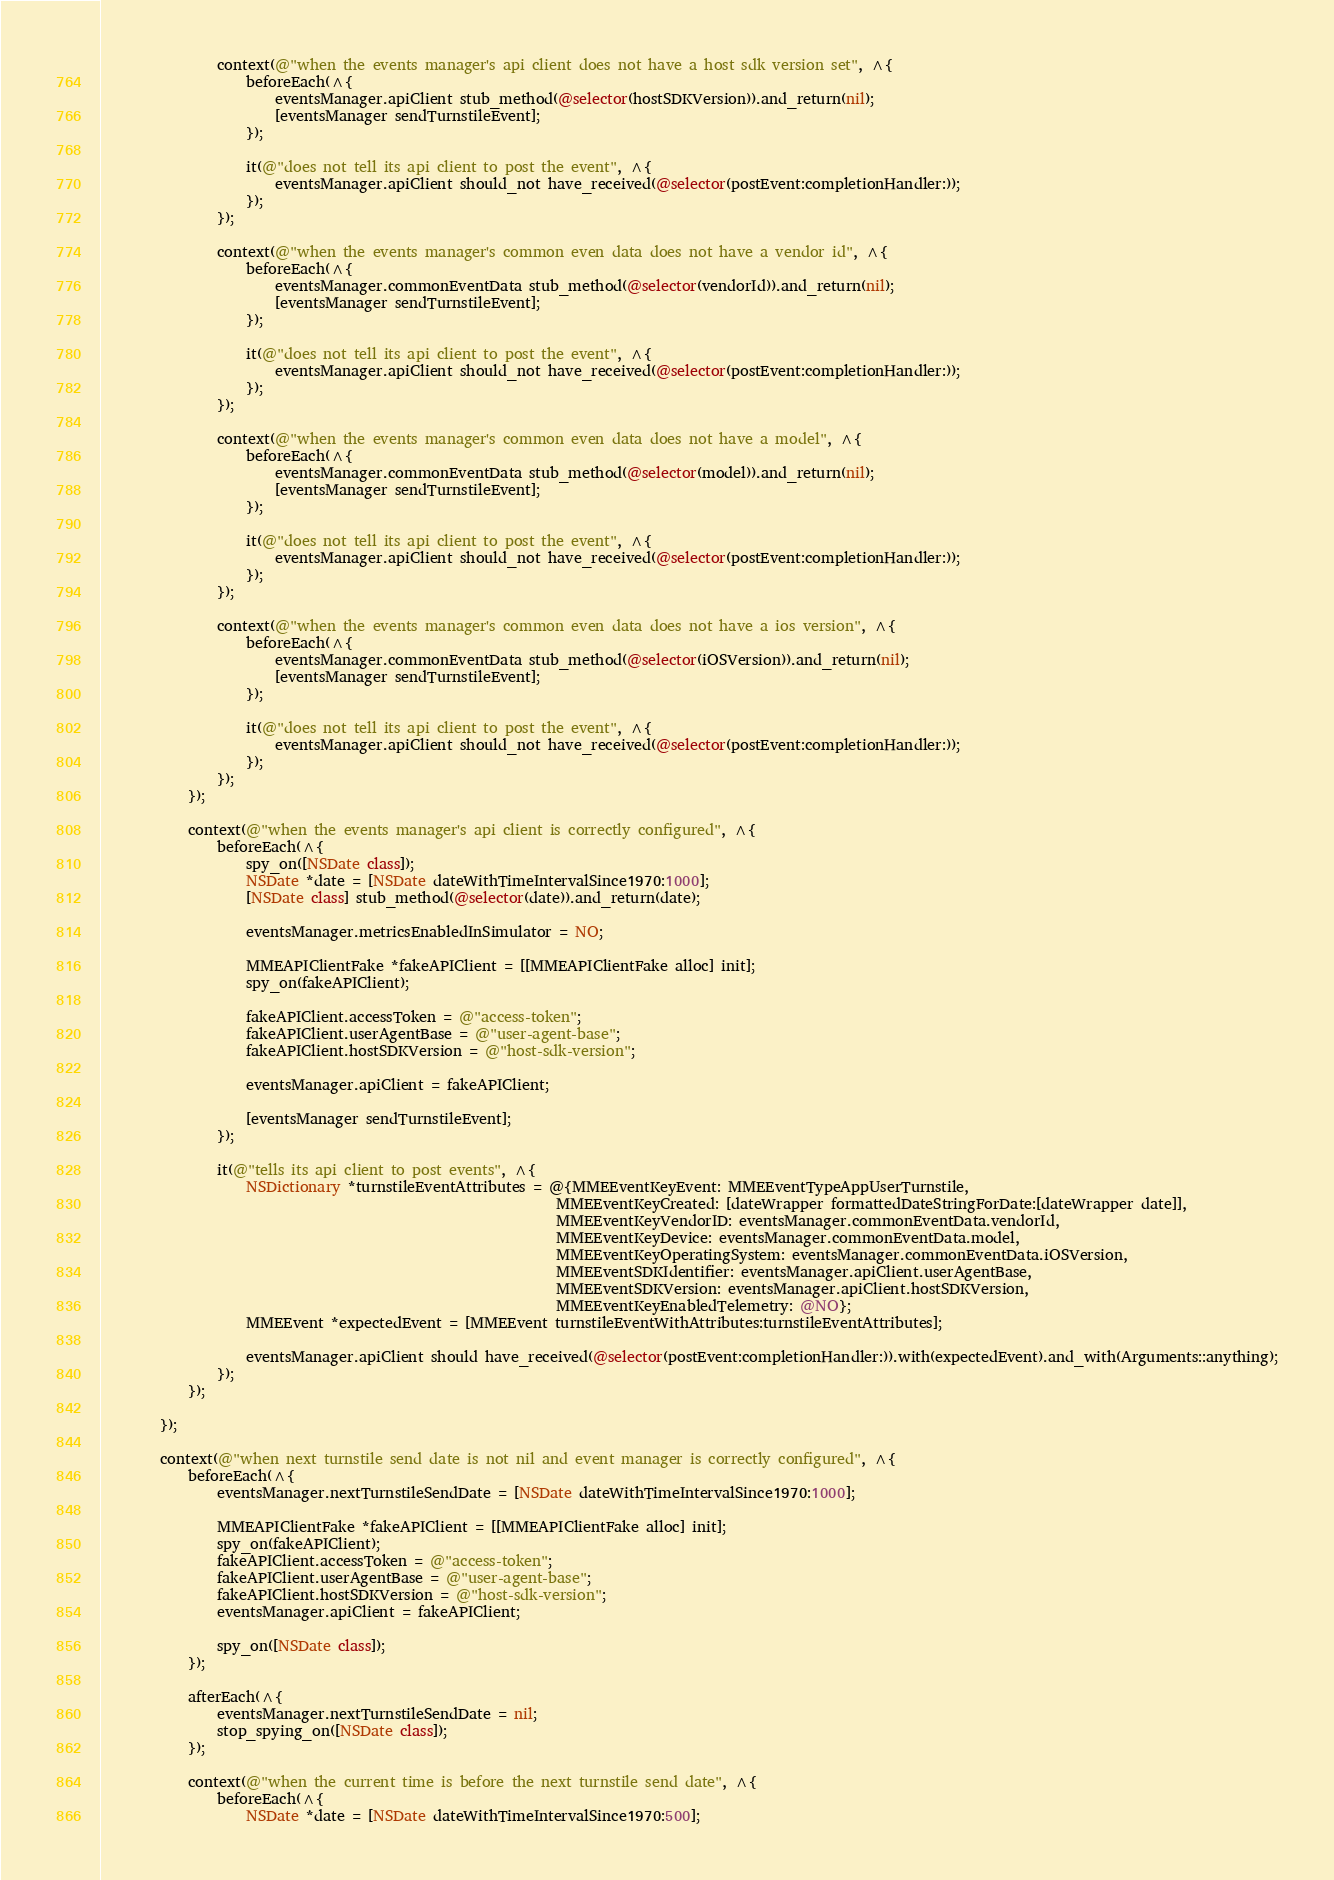Convert code to text. <code><loc_0><loc_0><loc_500><loc_500><_ObjectiveC_>                context(@"when the events manager's api client does not have a host sdk version set", ^{
                    beforeEach(^{
                        eventsManager.apiClient stub_method(@selector(hostSDKVersion)).and_return(nil);
                        [eventsManager sendTurnstileEvent];
                    });
                    
                    it(@"does not tell its api client to post the event", ^{
                        eventsManager.apiClient should_not have_received(@selector(postEvent:completionHandler:));
                    });
                });
                
                context(@"when the events manager's common even data does not have a vendor id", ^{
                    beforeEach(^{
                        eventsManager.commonEventData stub_method(@selector(vendorId)).and_return(nil);
                        [eventsManager sendTurnstileEvent];
                    });
                    
                    it(@"does not tell its api client to post the event", ^{
                        eventsManager.apiClient should_not have_received(@selector(postEvent:completionHandler:));
                    });
                });
                
                context(@"when the events manager's common even data does not have a model", ^{
                    beforeEach(^{
                        eventsManager.commonEventData stub_method(@selector(model)).and_return(nil);
                        [eventsManager sendTurnstileEvent];
                    });
                    
                    it(@"does not tell its api client to post the event", ^{
                        eventsManager.apiClient should_not have_received(@selector(postEvent:completionHandler:));
                    });
                });
                
                context(@"when the events manager's common even data does not have a ios version", ^{
                    beforeEach(^{
                        eventsManager.commonEventData stub_method(@selector(iOSVersion)).and_return(nil);
                        [eventsManager sendTurnstileEvent];
                    });
                    
                    it(@"does not tell its api client to post the event", ^{
                        eventsManager.apiClient should_not have_received(@selector(postEvent:completionHandler:));
                    });
                });
            });
            
            context(@"when the events manager's api client is correctly configured", ^{
                beforeEach(^{
                    spy_on([NSDate class]);
                    NSDate *date = [NSDate dateWithTimeIntervalSince1970:1000];
                    [NSDate class] stub_method(@selector(date)).and_return(date);
                    
                    eventsManager.metricsEnabledInSimulator = NO;
                    
                    MMEAPIClientFake *fakeAPIClient = [[MMEAPIClientFake alloc] init];
                    spy_on(fakeAPIClient);
                    
                    fakeAPIClient.accessToken = @"access-token";
                    fakeAPIClient.userAgentBase = @"user-agent-base";
                    fakeAPIClient.hostSDKVersion = @"host-sdk-version";
                    
                    eventsManager.apiClient = fakeAPIClient;
                    
                    [eventsManager sendTurnstileEvent];
                });
                
                it(@"tells its api client to post events", ^{
                    NSDictionary *turnstileEventAttributes = @{MMEEventKeyEvent: MMEEventTypeAppUserTurnstile,
                                                               MMEEventKeyCreated: [dateWrapper formattedDateStringForDate:[dateWrapper date]],
                                                               MMEEventKeyVendorID: eventsManager.commonEventData.vendorId,
                                                               MMEEventKeyDevice: eventsManager.commonEventData.model,
                                                               MMEEventKeyOperatingSystem: eventsManager.commonEventData.iOSVersion,
                                                               MMEEventSDKIdentifier: eventsManager.apiClient.userAgentBase,
                                                               MMEEventSDKVersion: eventsManager.apiClient.hostSDKVersion,
                                                               MMEEventKeyEnabledTelemetry: @NO};
                    MMEEvent *expectedEvent = [MMEEvent turnstileEventWithAttributes:turnstileEventAttributes];
                    
                    eventsManager.apiClient should have_received(@selector(postEvent:completionHandler:)).with(expectedEvent).and_with(Arguments::anything);
                });
            });
            
        });
        
        context(@"when next turnstile send date is not nil and event manager is correctly configured", ^{
            beforeEach(^{
                eventsManager.nextTurnstileSendDate = [NSDate dateWithTimeIntervalSince1970:1000];
                
                MMEAPIClientFake *fakeAPIClient = [[MMEAPIClientFake alloc] init];
                spy_on(fakeAPIClient);
                fakeAPIClient.accessToken = @"access-token";
                fakeAPIClient.userAgentBase = @"user-agent-base";
                fakeAPIClient.hostSDKVersion = @"host-sdk-version";
                eventsManager.apiClient = fakeAPIClient;
                
                spy_on([NSDate class]);
            });
            
            afterEach(^{
                eventsManager.nextTurnstileSendDate = nil;
                stop_spying_on([NSDate class]);
            });

            context(@"when the current time is before the next turnstile send date", ^{
                beforeEach(^{
                    NSDate *date = [NSDate dateWithTimeIntervalSince1970:500];</code> 